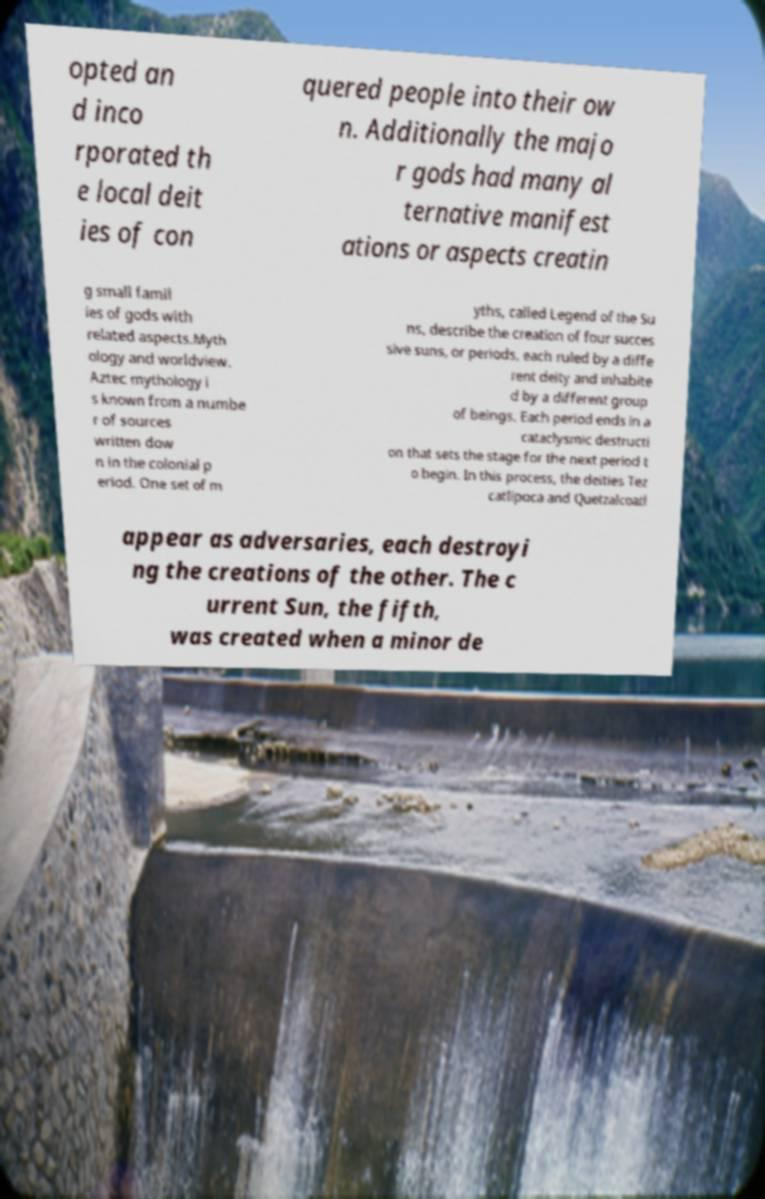Could you extract and type out the text from this image? opted an d inco rporated th e local deit ies of con quered people into their ow n. Additionally the majo r gods had many al ternative manifest ations or aspects creatin g small famil ies of gods with related aspects.Myth ology and worldview. Aztec mythology i s known from a numbe r of sources written dow n in the colonial p eriod. One set of m yths, called Legend of the Su ns, describe the creation of four succes sive suns, or periods, each ruled by a diffe rent deity and inhabite d by a different group of beings. Each period ends in a cataclysmic destructi on that sets the stage for the next period t o begin. In this process, the deities Tez catlipoca and Quetzalcoatl appear as adversaries, each destroyi ng the creations of the other. The c urrent Sun, the fifth, was created when a minor de 